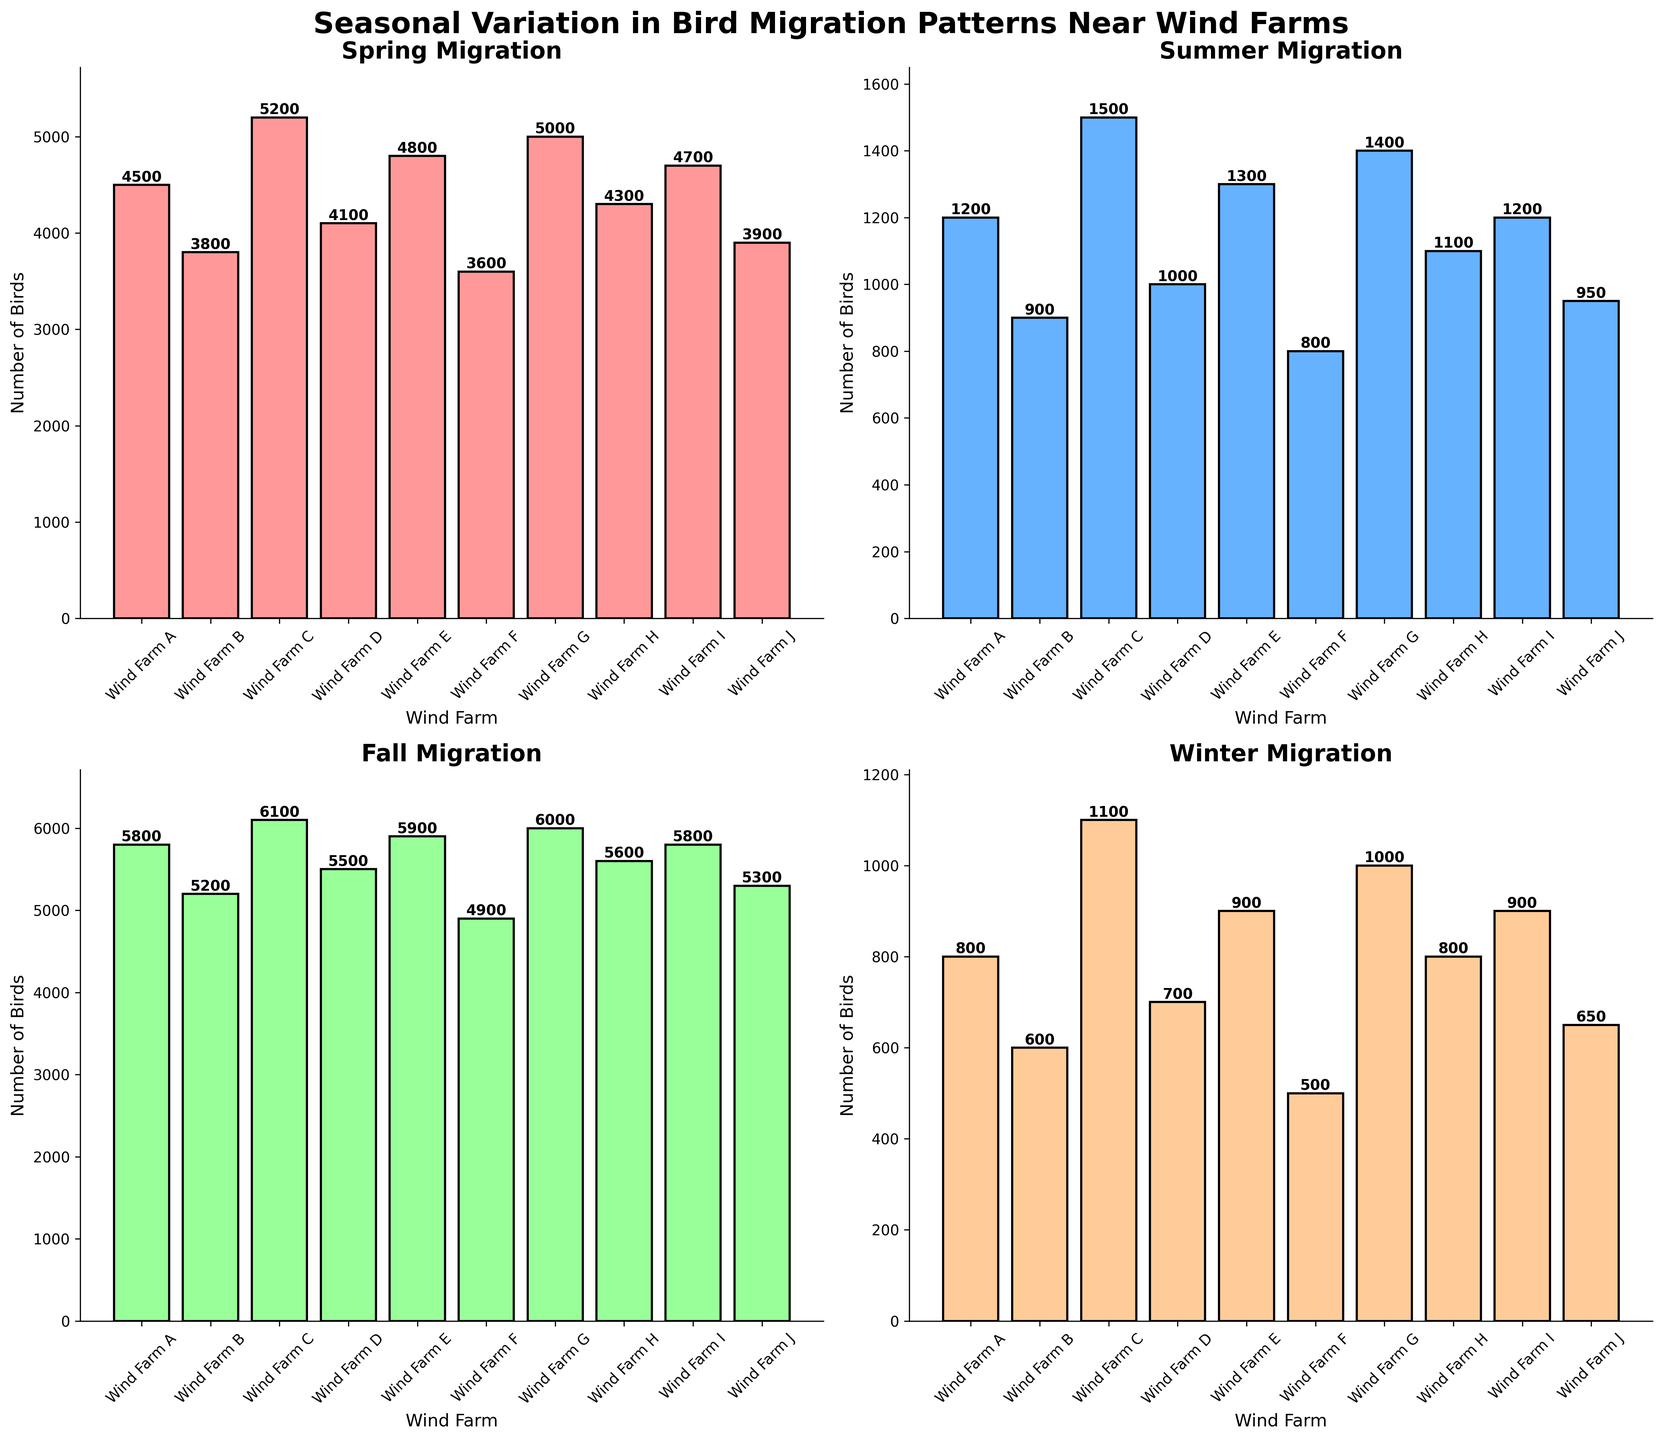what is the difference in the number of birds observed in the spring versus the winter for Wind Farm C? To find this, look at the bar heights for Wind Farm C in the respective subplots. Wind Farm C observed 5200 birds in spring and 1100 birds in winter. Subtract winter's count from spring's count: 5200 - 1100 = 4100.
Answer: 4100 Which wind farm has the highest number of birds observed in the fall? Look for the tallest bar in the Fall Migration subplot. The tallest bar belongs to Wind Farm C with 6100 birds.
Answer: Wind Farm C What's the average number of birds observed in summer across all wind farms? Sum the counts for summer across all wind farms and divide by the number of wind farms. Sum: 1200 + 900 + 1500 + 1000 + 1300 + 800 + 1400 + 1100 + 1200 + 950 = 12350. Divide by 10 wind farms: 12350 / 10 = 1235.
Answer: 1235 Which season shows the least variation in bird counts across wind farms? Observe the bar heights across all four seasons; the Summer subplots have bars that are more uniform in height compared to other seasons.
Answer: Summer Compare bird numbers in Wind Farm G in spring and fall. Which season has more birds? Look at the bars for Wind Farm G in the Spring and Fall subplots. Wind Farm G observed 5000 birds in spring and 6000 birds in fall. Fall has more birds.
Answer: Fall In which season is the difference between the wind farm with the most birds and the wind farm with the fewest birds the greatest? Compare the maximum and minimum bar heights in each subplot. In Fall, Wind Farm C has 6100 birds and Wind Farm F has 4900 birds: Difference is 1200. Other seasons have smaller differences.
Answer: Fall How many more birds are observed on average in spring compared to winter? Calculate the average number of birds in spring and winter. Spring: (4500 + 3800 + 5200 + 4100 + 4800 + 3600 + 5000 + 4300 + 4700 + 3900) / 10 = 43900 / 10 = 4390. Winter: (800 + 600 + 1100 + 700 + 900 + 500 + 1000 + 800 + 900 + 650) / 10 = 7950 / 10 = 795. Difference: 4390 - 795 = 3595.
Answer: 3595 